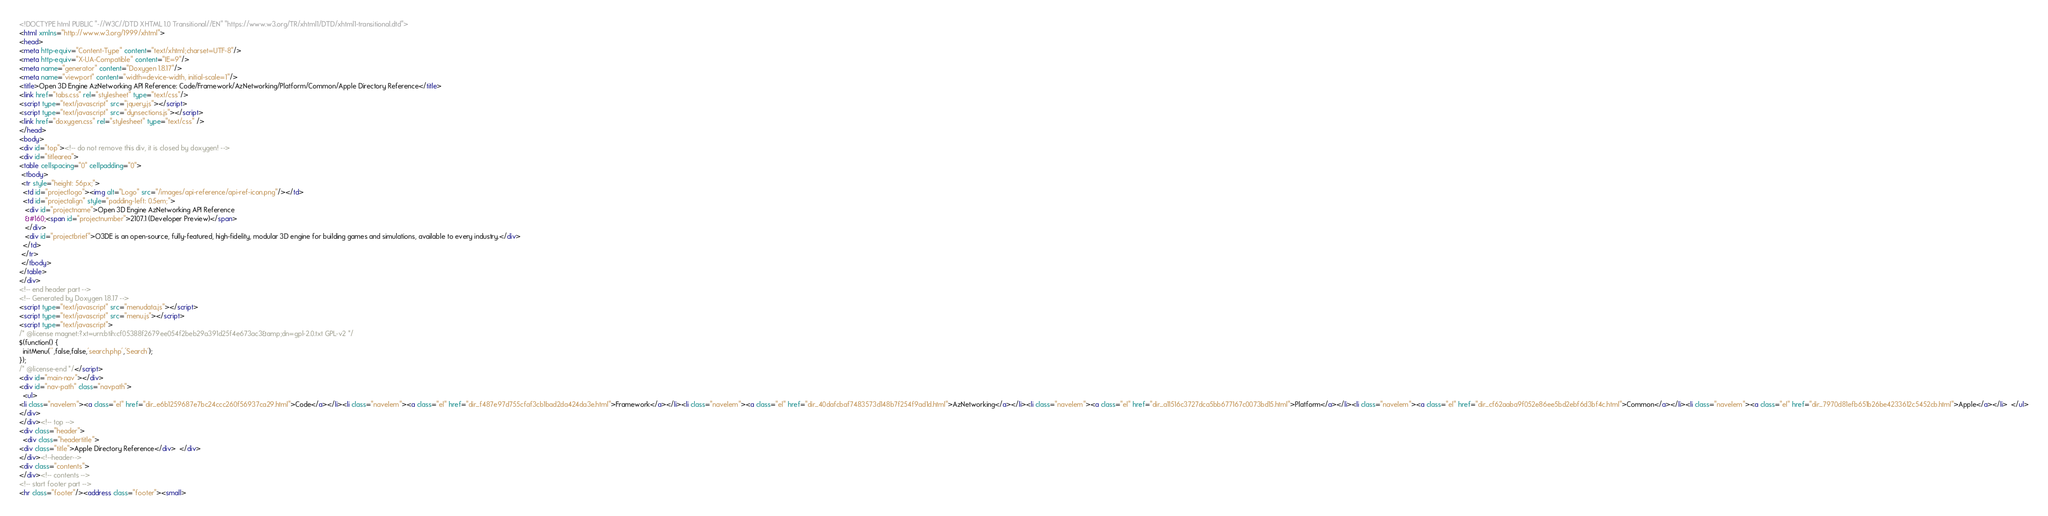Convert code to text. <code><loc_0><loc_0><loc_500><loc_500><_HTML_><!DOCTYPE html PUBLIC "-//W3C//DTD XHTML 1.0 Transitional//EN" "https://www.w3.org/TR/xhtml1/DTD/xhtml1-transitional.dtd">
<html xmlns="http://www.w3.org/1999/xhtml">
<head>
<meta http-equiv="Content-Type" content="text/xhtml;charset=UTF-8"/>
<meta http-equiv="X-UA-Compatible" content="IE=9"/>
<meta name="generator" content="Doxygen 1.8.17"/>
<meta name="viewport" content="width=device-width, initial-scale=1"/>
<title>Open 3D Engine AzNetworking API Reference: Code/Framework/AzNetworking/Platform/Common/Apple Directory Reference</title>
<link href="tabs.css" rel="stylesheet" type="text/css"/>
<script type="text/javascript" src="jquery.js"></script>
<script type="text/javascript" src="dynsections.js"></script>
<link href="doxygen.css" rel="stylesheet" type="text/css" />
</head>
<body>
<div id="top"><!-- do not remove this div, it is closed by doxygen! -->
<div id="titlearea">
<table cellspacing="0" cellpadding="0">
 <tbody>
 <tr style="height: 56px;">
  <td id="projectlogo"><img alt="Logo" src="/images/api-reference/api-ref-icon.png"/></td>
  <td id="projectalign" style="padding-left: 0.5em;">
   <div id="projectname">Open 3D Engine AzNetworking API Reference
   &#160;<span id="projectnumber">2107.1 (Developer Preview)</span>
   </div>
   <div id="projectbrief">O3DE is an open-source, fully-featured, high-fidelity, modular 3D engine for building games and simulations, available to every industry.</div>
  </td>
 </tr>
 </tbody>
</table>
</div>
<!-- end header part -->
<!-- Generated by Doxygen 1.8.17 -->
<script type="text/javascript" src="menudata.js"></script>
<script type="text/javascript" src="menu.js"></script>
<script type="text/javascript">
/* @license magnet:?xt=urn:btih:cf05388f2679ee054f2beb29a391d25f4e673ac3&amp;dn=gpl-2.0.txt GPL-v2 */
$(function() {
  initMenu('',false,false,'search.php','Search');
});
/* @license-end */</script>
<div id="main-nav"></div>
<div id="nav-path" class="navpath">
  <ul>
<li class="navelem"><a class="el" href="dir_e6b1259687e7bc24ccc260f56937ca29.html">Code</a></li><li class="navelem"><a class="el" href="dir_f487e97d755cfaf3cb1bad2da424da3e.html">Framework</a></li><li class="navelem"><a class="el" href="dir_40dafcbaf7483573d148b7f254f9ad1d.html">AzNetworking</a></li><li class="navelem"><a class="el" href="dir_a11516c3727dca5bb677167c0073bd15.html">Platform</a></li><li class="navelem"><a class="el" href="dir_cf62aaba9f052e86ee5bd2ebf6d3bf4c.html">Common</a></li><li class="navelem"><a class="el" href="dir_7970d81efb651b26be4233612c5452cb.html">Apple</a></li>  </ul>
</div>
</div><!-- top -->
<div class="header">
  <div class="headertitle">
<div class="title">Apple Directory Reference</div>  </div>
</div><!--header-->
<div class="contents">
</div><!-- contents -->
<!-- start footer part -->
<hr class="footer"/><address class="footer"><small></code> 